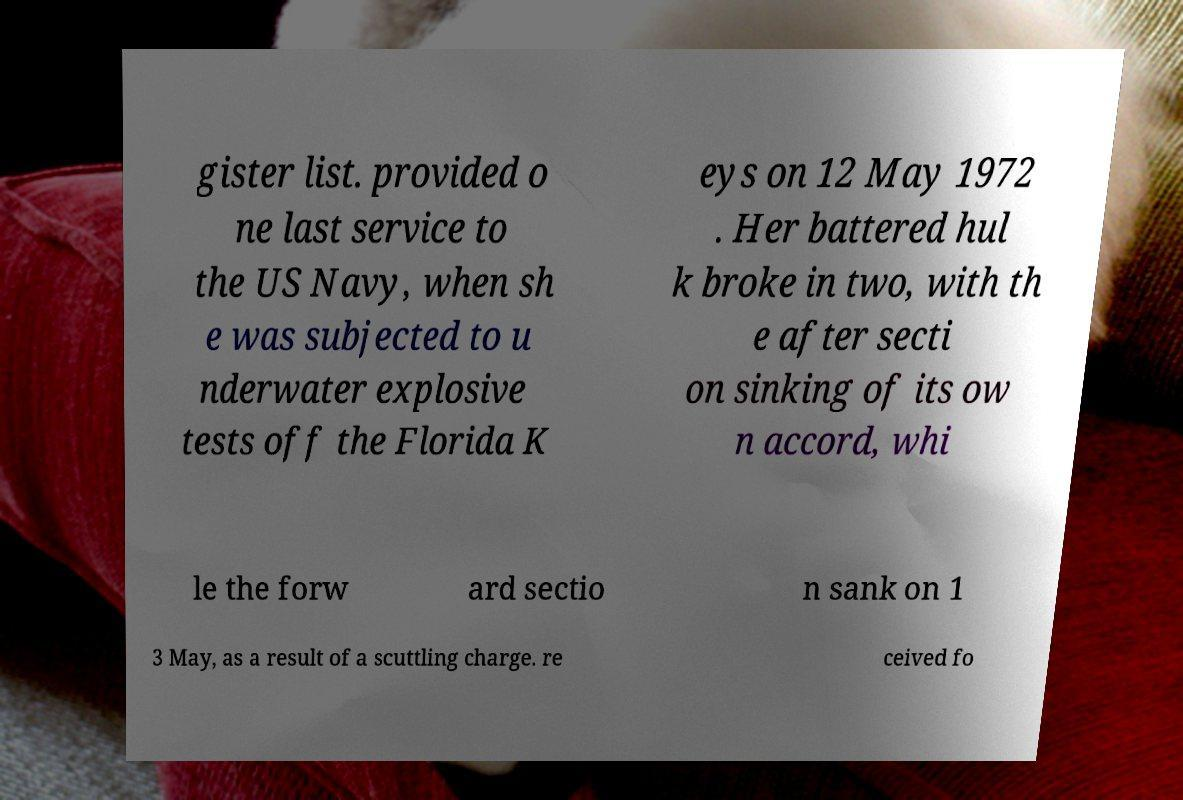What messages or text are displayed in this image? I need them in a readable, typed format. gister list. provided o ne last service to the US Navy, when sh e was subjected to u nderwater explosive tests off the Florida K eys on 12 May 1972 . Her battered hul k broke in two, with th e after secti on sinking of its ow n accord, whi le the forw ard sectio n sank on 1 3 May, as a result of a scuttling charge. re ceived fo 